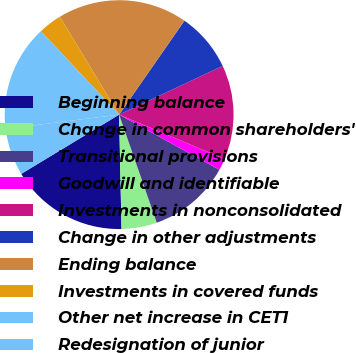Convert chart. <chart><loc_0><loc_0><loc_500><loc_500><pie_chart><fcel>Beginning balance<fcel>Change in common shareholders'<fcel>Transitional provisions<fcel>Goodwill and identifiable<fcel>Investments in nonconsolidated<fcel>Change in other adjustments<fcel>Ending balance<fcel>Investments in covered funds<fcel>Other net increase in CET1<fcel>Redesignation of junior<nl><fcel>16.67%<fcel>5.0%<fcel>11.67%<fcel>1.67%<fcel>13.33%<fcel>8.33%<fcel>18.33%<fcel>3.33%<fcel>15.0%<fcel>6.67%<nl></chart> 